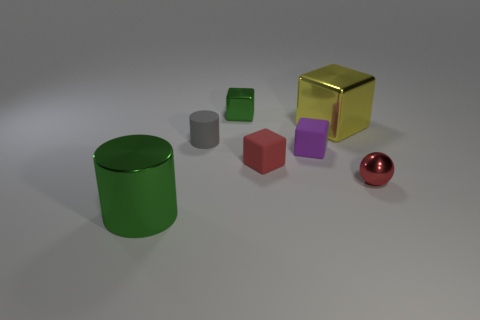Subtract 1 blocks. How many blocks are left? 3 Add 2 purple rubber things. How many objects exist? 9 Subtract all spheres. How many objects are left? 6 Add 4 green cubes. How many green cubes are left? 5 Add 6 small purple matte things. How many small purple matte things exist? 7 Subtract 1 purple cubes. How many objects are left? 6 Subtract all purple objects. Subtract all gray matte balls. How many objects are left? 6 